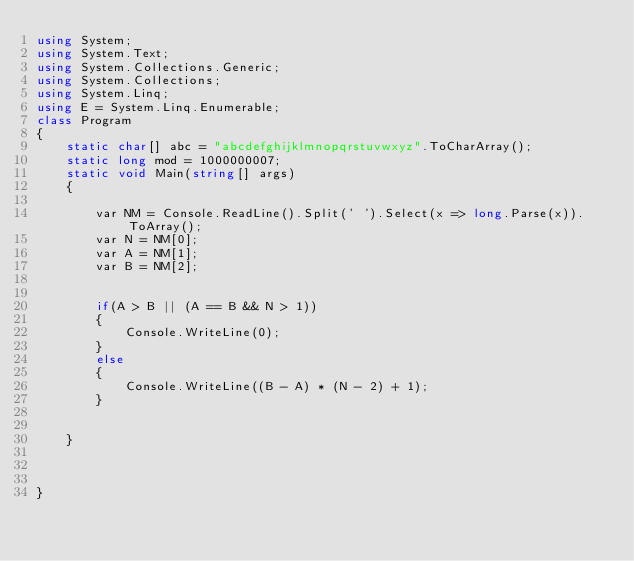Convert code to text. <code><loc_0><loc_0><loc_500><loc_500><_C#_>using System;
using System.Text;
using System.Collections.Generic;
using System.Collections;
using System.Linq;
using E = System.Linq.Enumerable;
class Program
{
    static char[] abc = "abcdefghijklmnopqrstuvwxyz".ToCharArray();
    static long mod = 1000000007;
    static void Main(string[] args)
    {

        var NM = Console.ReadLine().Split(' ').Select(x => long.Parse(x)).ToArray();
        var N = NM[0];
        var A = NM[1];
        var B = NM[2];


        if(A > B || (A == B && N > 1))
        {
            Console.WriteLine(0);
        }
        else
        {
            Console.WriteLine((B - A) * (N - 2) + 1);
        }
        

    }


    
}
</code> 